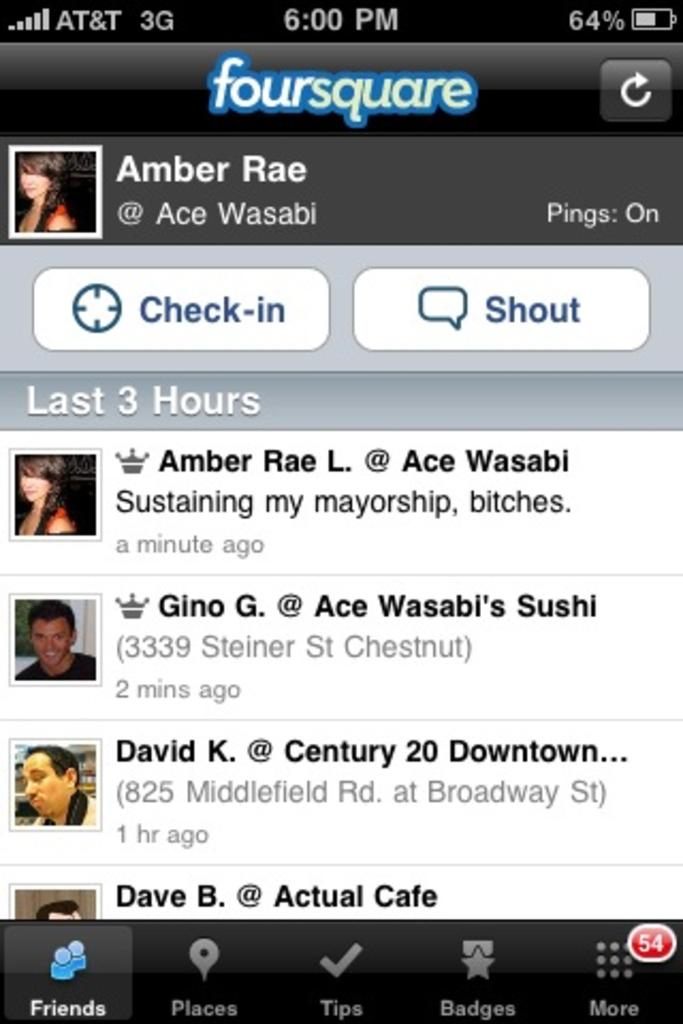What is the main subject of the image? The main subject of the image is a screenshot. What can be seen on the screenshot? The screenshot contains text and persons. How many bikes are visible on the screenshot? There are no bikes visible on the screenshot; it only contains text and persons. What type of land can be seen in the background of the screenshot? There is no land visible in the screenshot, as it is a screenshot of a digital interface. 